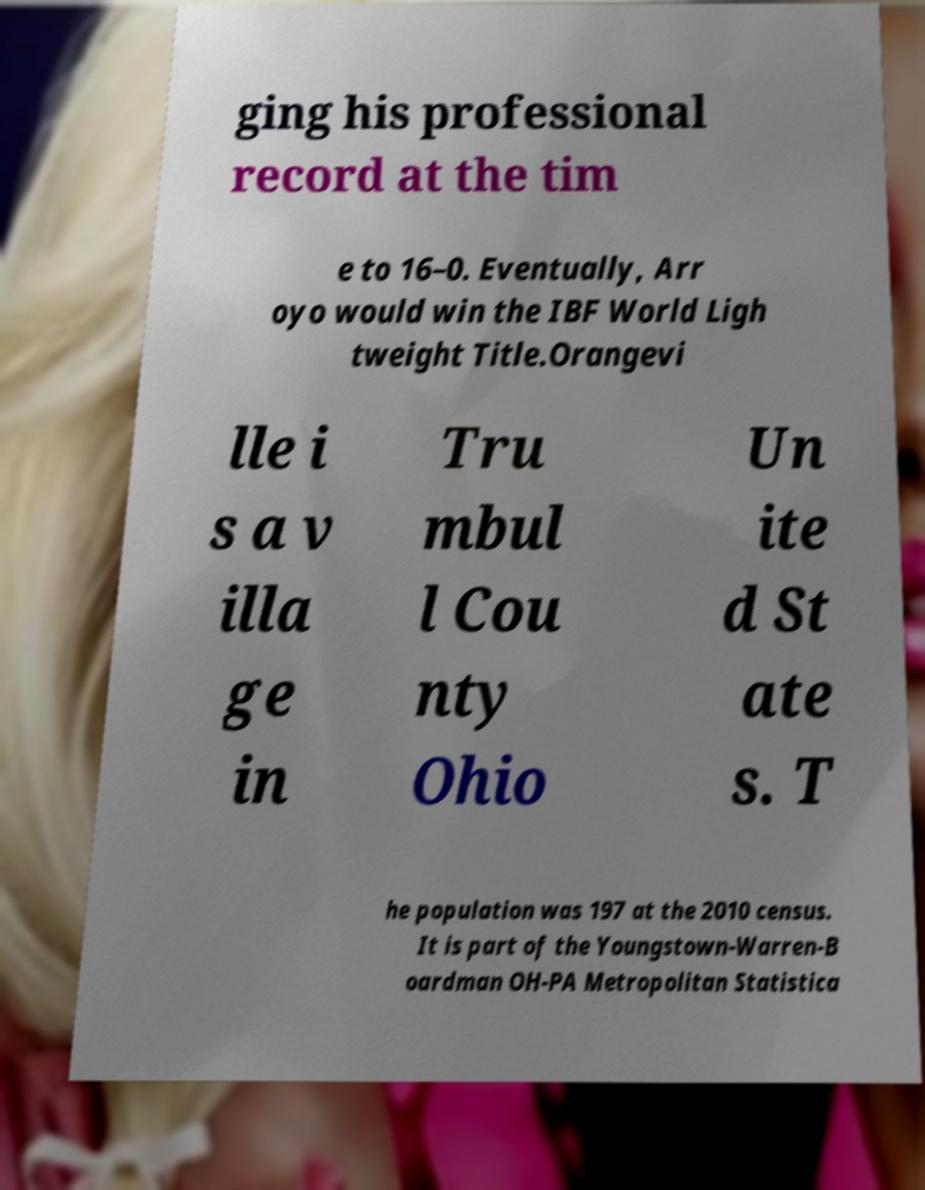There's text embedded in this image that I need extracted. Can you transcribe it verbatim? ging his professional record at the tim e to 16–0. Eventually, Arr oyo would win the IBF World Ligh tweight Title.Orangevi lle i s a v illa ge in Tru mbul l Cou nty Ohio Un ite d St ate s. T he population was 197 at the 2010 census. It is part of the Youngstown-Warren-B oardman OH-PA Metropolitan Statistica 